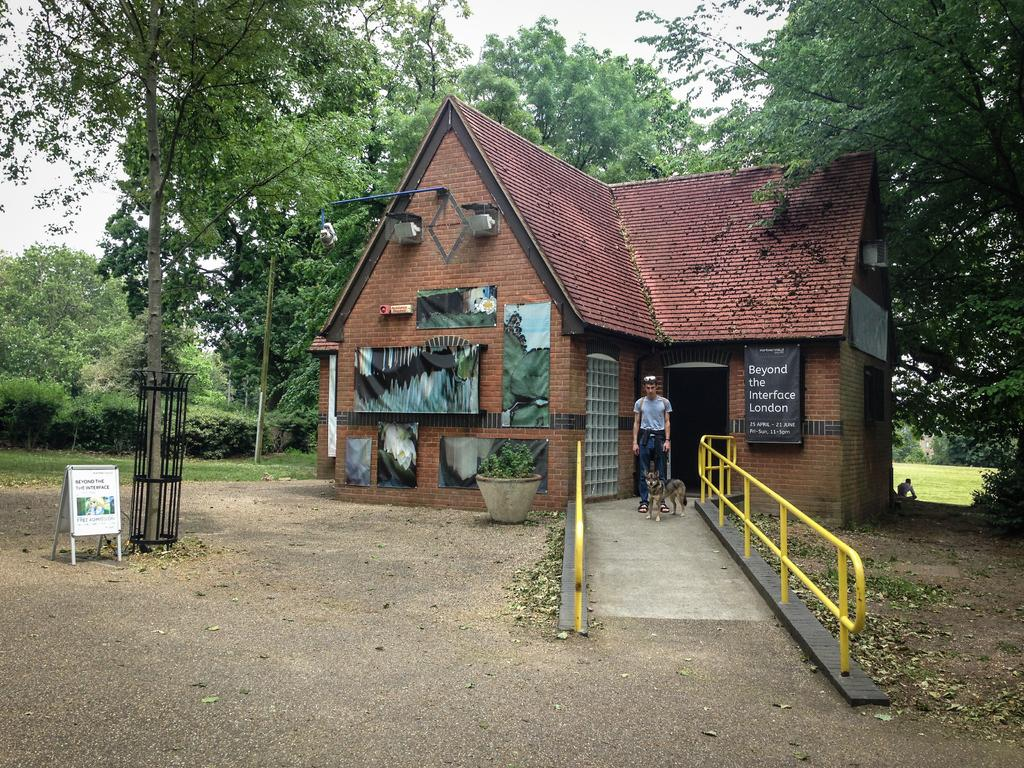<image>
Share a concise interpretation of the image provided. A person standing outside a building with the sign beyond the interface London. 